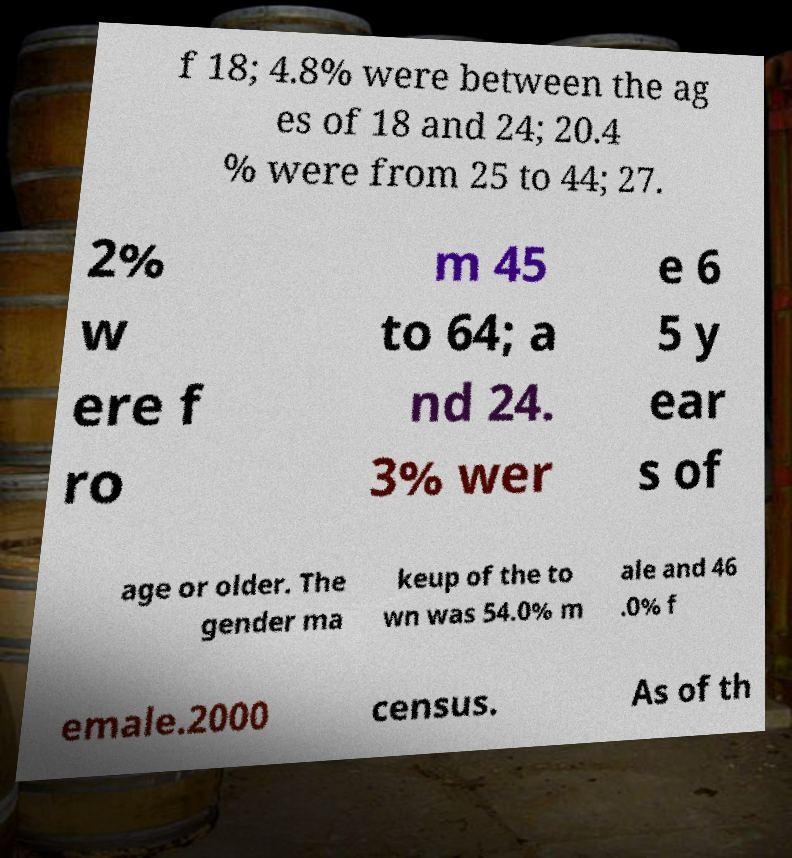I need the written content from this picture converted into text. Can you do that? f 18; 4.8% were between the ag es of 18 and 24; 20.4 % were from 25 to 44; 27. 2% w ere f ro m 45 to 64; a nd 24. 3% wer e 6 5 y ear s of age or older. The gender ma keup of the to wn was 54.0% m ale and 46 .0% f emale.2000 census. As of th 